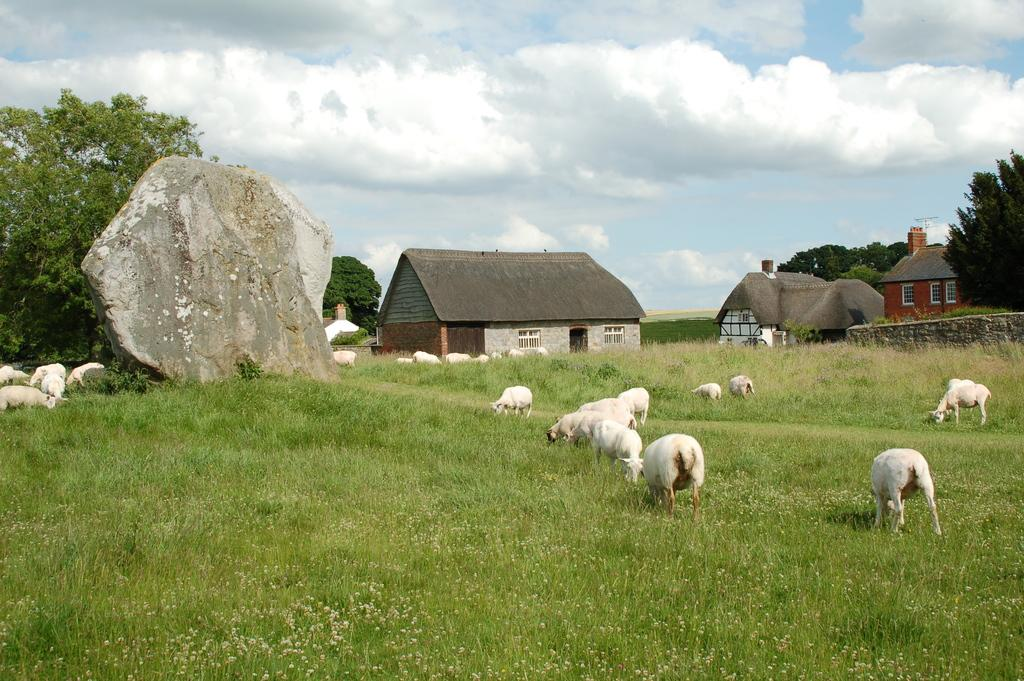What animals can be seen in the field in the image? There are sheep in the field in the image. What can be seen in the background of the image? There are trees, houses, rocks, and clouds in the background of the image. What type of wood can be seen in the image? There is no wood present in the image. How much dust is visible in the image? There is no dust visible in the image. 